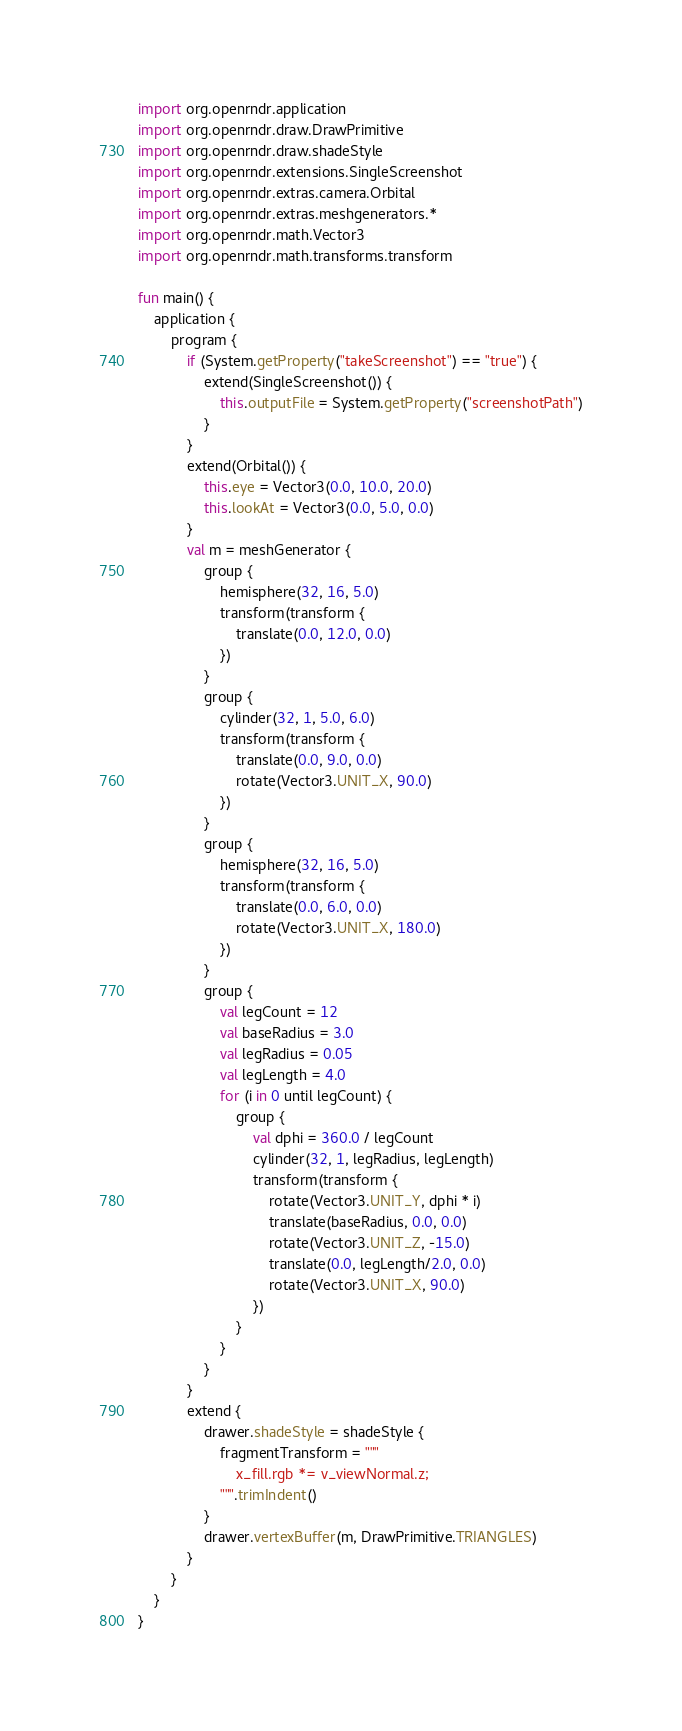Convert code to text. <code><loc_0><loc_0><loc_500><loc_500><_Kotlin_>import org.openrndr.application
import org.openrndr.draw.DrawPrimitive
import org.openrndr.draw.shadeStyle
import org.openrndr.extensions.SingleScreenshot
import org.openrndr.extras.camera.Orbital
import org.openrndr.extras.meshgenerators.*
import org.openrndr.math.Vector3
import org.openrndr.math.transforms.transform

fun main() {
    application {
        program {
            if (System.getProperty("takeScreenshot") == "true") {
                extend(SingleScreenshot()) {
                    this.outputFile = System.getProperty("screenshotPath")
                }
            }
            extend(Orbital()) {
                this.eye = Vector3(0.0, 10.0, 20.0)
                this.lookAt = Vector3(0.0, 5.0, 0.0)
            }
            val m = meshGenerator {
                group {
                    hemisphere(32, 16, 5.0)
                    transform(transform {
                        translate(0.0, 12.0, 0.0)
                    })
                }
                group {
                    cylinder(32, 1, 5.0, 6.0)
                    transform(transform {
                        translate(0.0, 9.0, 0.0)
                        rotate(Vector3.UNIT_X, 90.0)
                    })
                }
                group {
                    hemisphere(32, 16, 5.0)
                    transform(transform {
                        translate(0.0, 6.0, 0.0)
                        rotate(Vector3.UNIT_X, 180.0)
                    })
                }
                group {
                    val legCount = 12
                    val baseRadius = 3.0
                    val legRadius = 0.05
                    val legLength = 4.0
                    for (i in 0 until legCount) {
                        group {
                            val dphi = 360.0 / legCount
                            cylinder(32, 1, legRadius, legLength)
                            transform(transform {
                                rotate(Vector3.UNIT_Y, dphi * i)
                                translate(baseRadius, 0.0, 0.0)
                                rotate(Vector3.UNIT_Z, -15.0)
                                translate(0.0, legLength/2.0, 0.0)
                                rotate(Vector3.UNIT_X, 90.0)
                            })
                        }
                    }
                }
            }
            extend {
                drawer.shadeStyle = shadeStyle {
                    fragmentTransform = """
                        x_fill.rgb *= v_viewNormal.z;
                    """.trimIndent()
                }
                drawer.vertexBuffer(m, DrawPrimitive.TRIANGLES)
            }
        }
    }
}</code> 